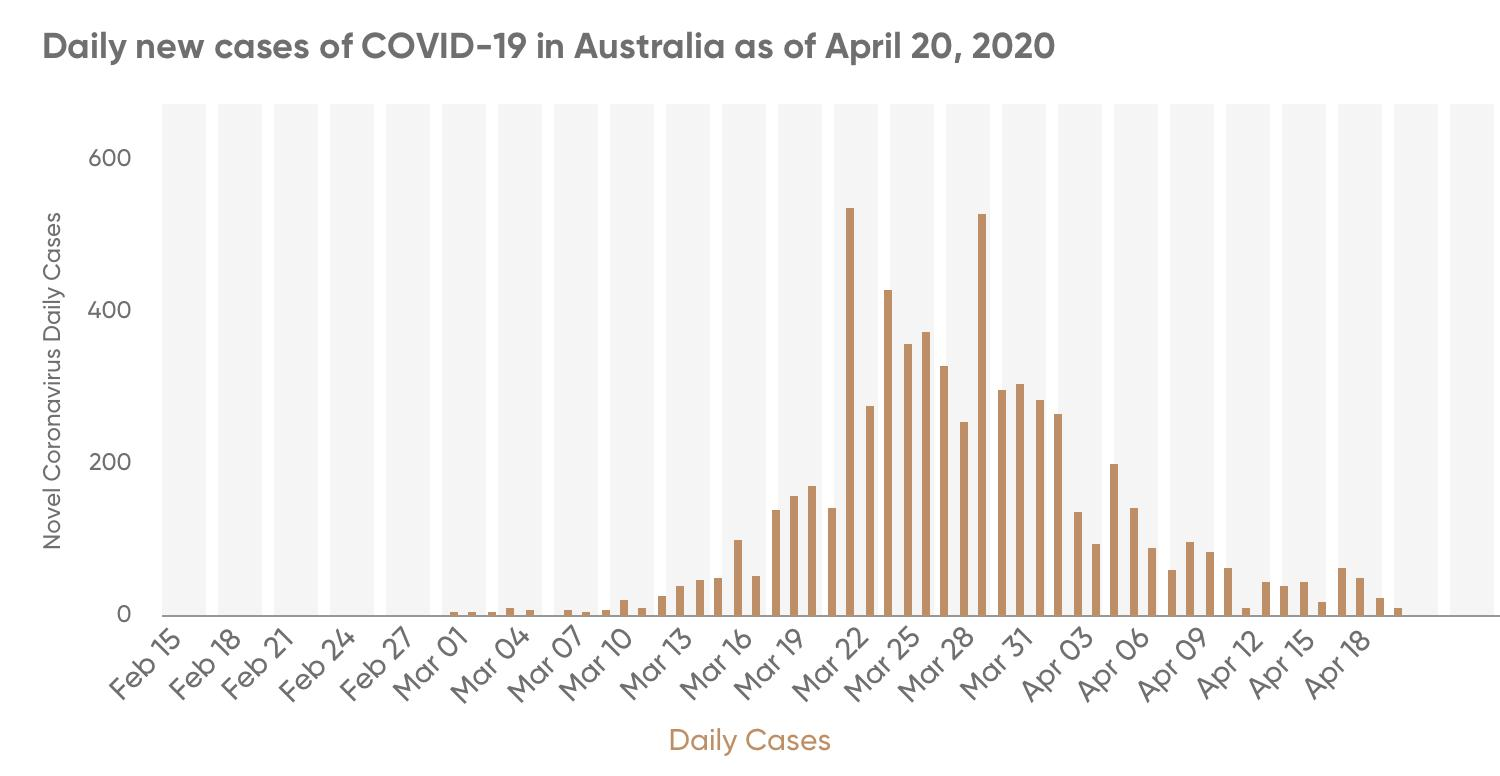List a handful of essential elements in this visual. The first reported case of Covid-19 in Australia was on March 1, 2020. 